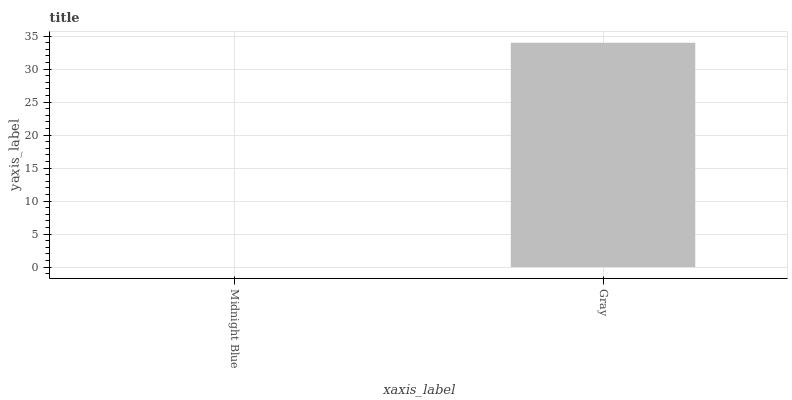Is Midnight Blue the minimum?
Answer yes or no. Yes. Is Gray the maximum?
Answer yes or no. Yes. Is Gray the minimum?
Answer yes or no. No. Is Gray greater than Midnight Blue?
Answer yes or no. Yes. Is Midnight Blue less than Gray?
Answer yes or no. Yes. Is Midnight Blue greater than Gray?
Answer yes or no. No. Is Gray less than Midnight Blue?
Answer yes or no. No. Is Gray the high median?
Answer yes or no. Yes. Is Midnight Blue the low median?
Answer yes or no. Yes. Is Midnight Blue the high median?
Answer yes or no. No. Is Gray the low median?
Answer yes or no. No. 